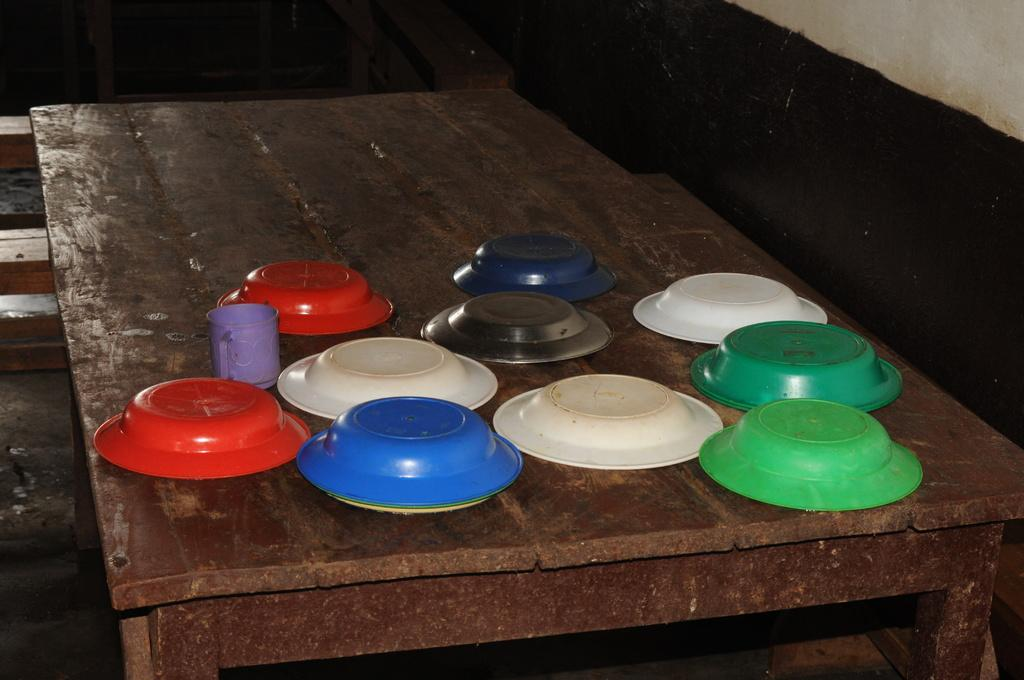What piece of furniture is present in the image? There is a table in the image. What is placed on the table? There is a cup and plates on the table. What can be seen in the background of the image? There is a wooden object and a wall visible in the background of the image. What time of day is it in the image, and what channel is the TV set to? There is no TV present in the image, so we cannot determine the time or the channel being watched. 